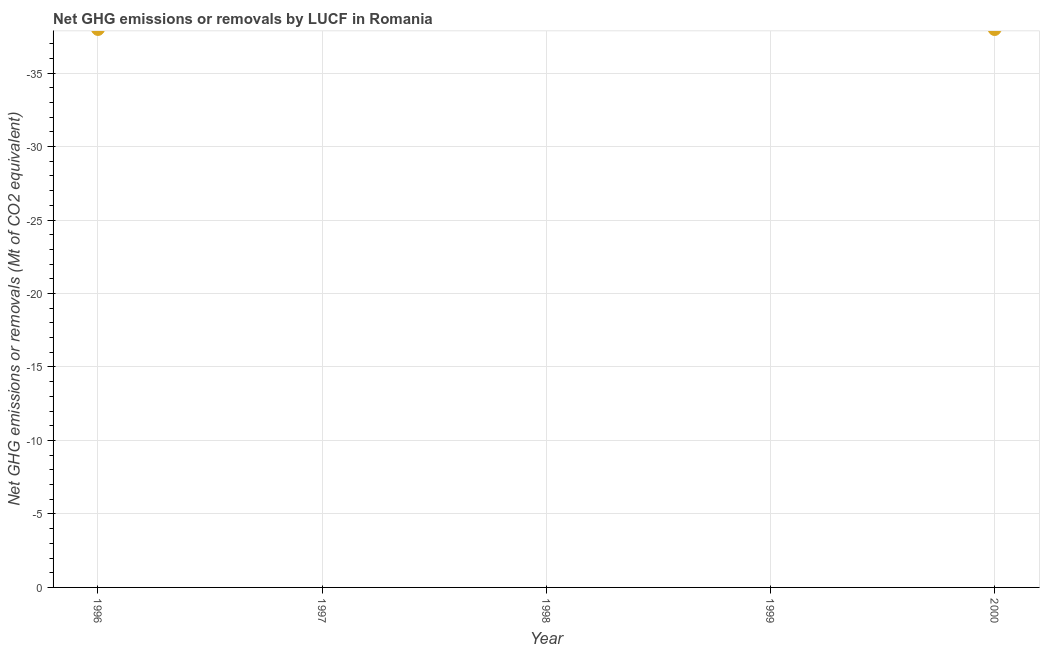What is the average ghg net emissions or removals per year?
Provide a short and direct response. 0. What is the median ghg net emissions or removals?
Provide a short and direct response. 0. Does the ghg net emissions or removals monotonically increase over the years?
Your response must be concise. No. How many dotlines are there?
Your response must be concise. 0. How many years are there in the graph?
Offer a very short reply. 5. What is the difference between two consecutive major ticks on the Y-axis?
Give a very brief answer. 5. Does the graph contain any zero values?
Your response must be concise. Yes. Does the graph contain grids?
Your answer should be very brief. Yes. What is the title of the graph?
Offer a very short reply. Net GHG emissions or removals by LUCF in Romania. What is the label or title of the X-axis?
Your answer should be very brief. Year. What is the label or title of the Y-axis?
Keep it short and to the point. Net GHG emissions or removals (Mt of CO2 equivalent). What is the Net GHG emissions or removals (Mt of CO2 equivalent) in 1997?
Provide a succinct answer. 0. What is the Net GHG emissions or removals (Mt of CO2 equivalent) in 1998?
Your response must be concise. 0. 